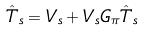<formula> <loc_0><loc_0><loc_500><loc_500>\hat { T } _ { s } = V _ { s } + V _ { s } G _ { \pi } \hat { T } _ { s }</formula> 